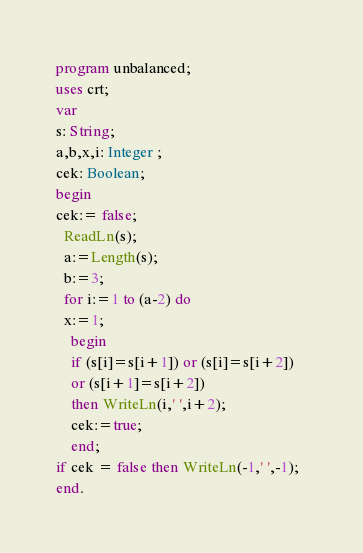<code> <loc_0><loc_0><loc_500><loc_500><_Pascal_>program unbalanced;
uses crt;
var
s: String;
a,b,x,i: Integer ;
cek: Boolean;
begin
cek:= false;
  ReadLn(s);
  a:=Length(s);
  b:=3;
  for i:=1 to (a-2) do
  x:=1;
    begin
    if (s[i]=s[i+1]) or (s[i]=s[i+2])
    or (s[i+1]=s[i+2])
    then WriteLn(i,' ',i+2);
    cek:=true;
    end;   
if cek = false then WriteLn(-1,' ',-1);  
end.</code> 